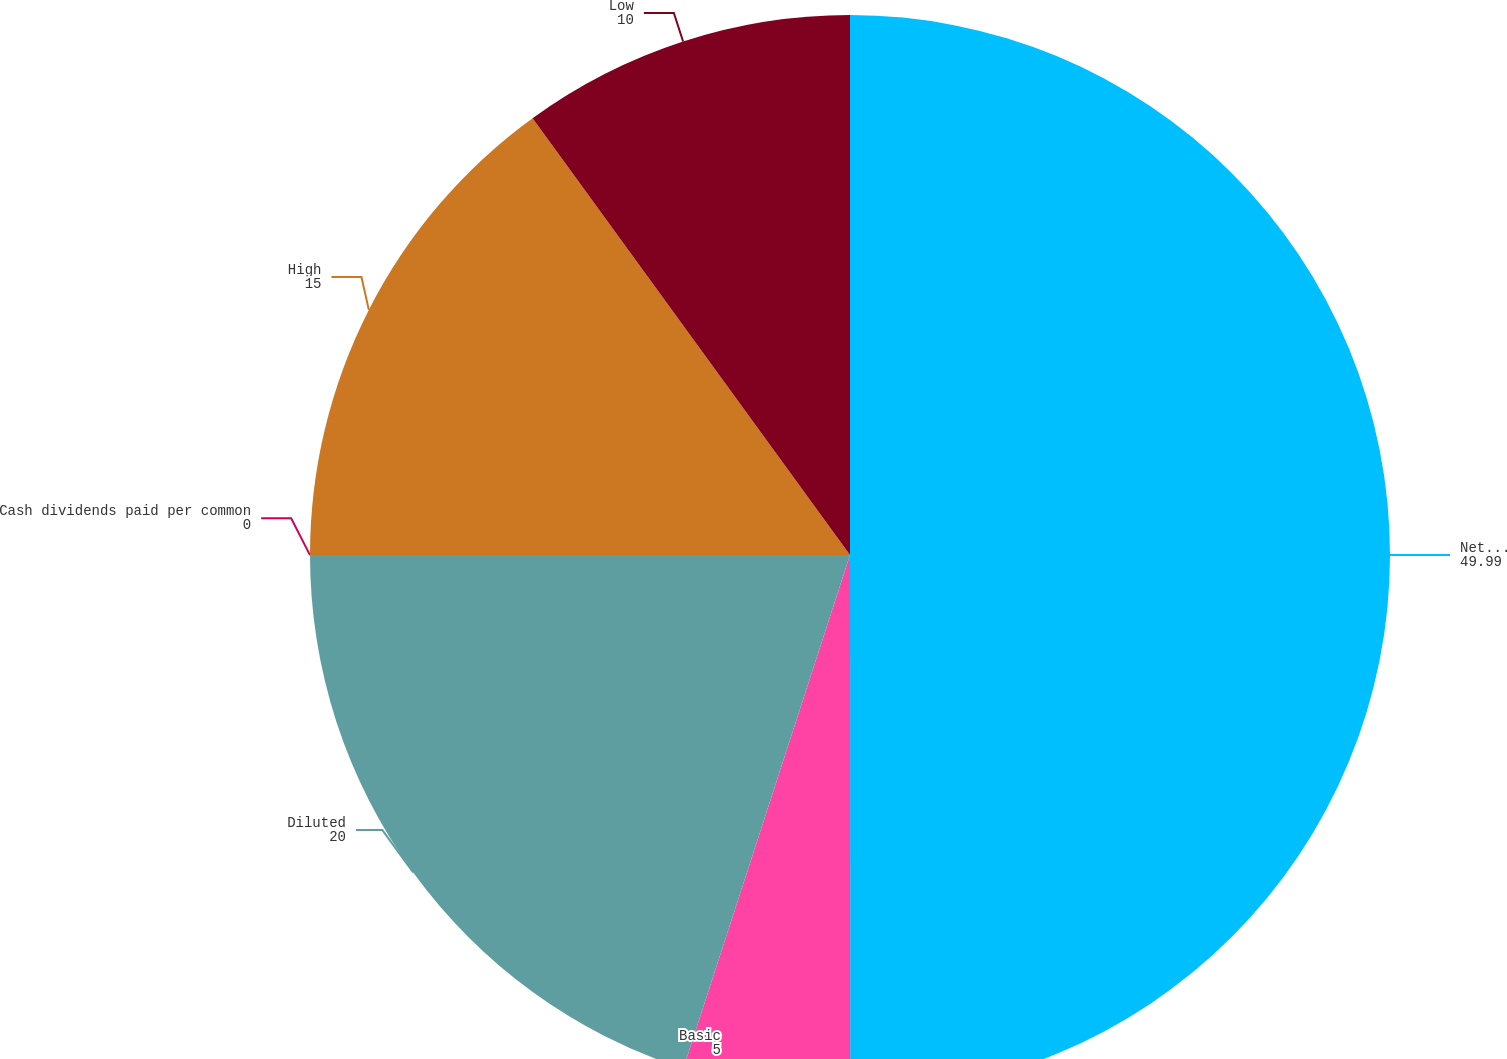<chart> <loc_0><loc_0><loc_500><loc_500><pie_chart><fcel>Net revenues (1)<fcel>Basic<fcel>Diluted<fcel>Cash dividends paid per common<fcel>High<fcel>Low<nl><fcel>49.99%<fcel>5.0%<fcel>20.0%<fcel>0.0%<fcel>15.0%<fcel>10.0%<nl></chart> 